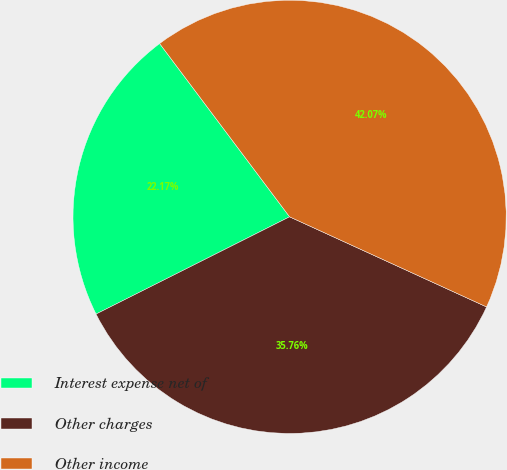<chart> <loc_0><loc_0><loc_500><loc_500><pie_chart><fcel>Interest expense net of<fcel>Other charges<fcel>Other income<nl><fcel>22.17%<fcel>35.76%<fcel>42.07%<nl></chart> 